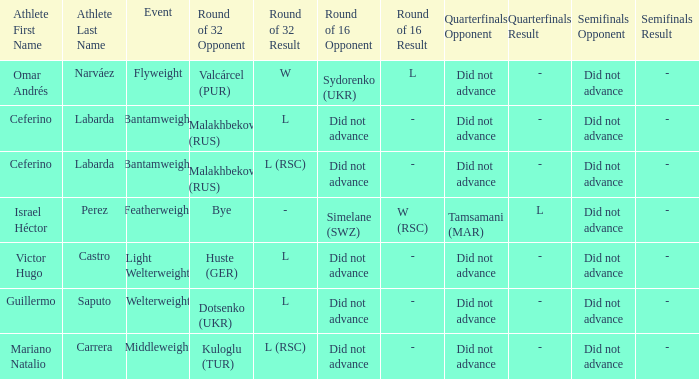When there was a bye in the round of 32, what was the result in the round of 16? Did not advance. 